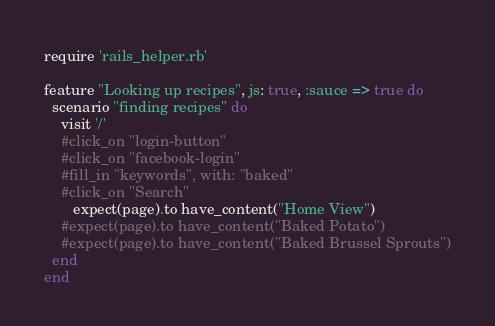Convert code to text. <code><loc_0><loc_0><loc_500><loc_500><_Ruby_>require 'rails_helper.rb'

feature "Looking up recipes", js: true, :sauce => true do
  scenario "finding recipes" do
    visit '/'
    #click_on "login-button"
    #click_on "facebook-login"
    #fill_in "keywords", with: "baked"
    #click_on "Search"
	   expect(page).to have_content("Home View")
    #expect(page).to have_content("Baked Potato")
    #expect(page).to have_content("Baked Brussel Sprouts")
  end
end</code> 